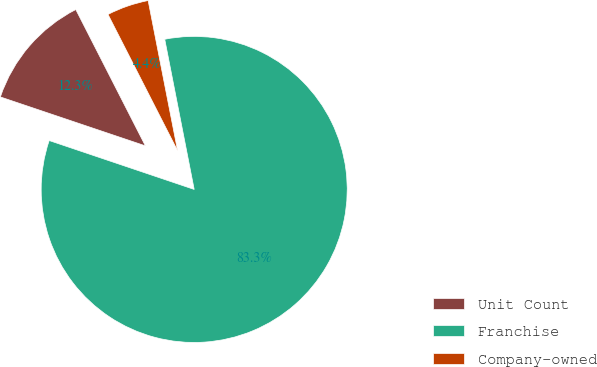<chart> <loc_0><loc_0><loc_500><loc_500><pie_chart><fcel>Unit Count<fcel>Franchise<fcel>Company-owned<nl><fcel>12.31%<fcel>83.26%<fcel>4.43%<nl></chart> 